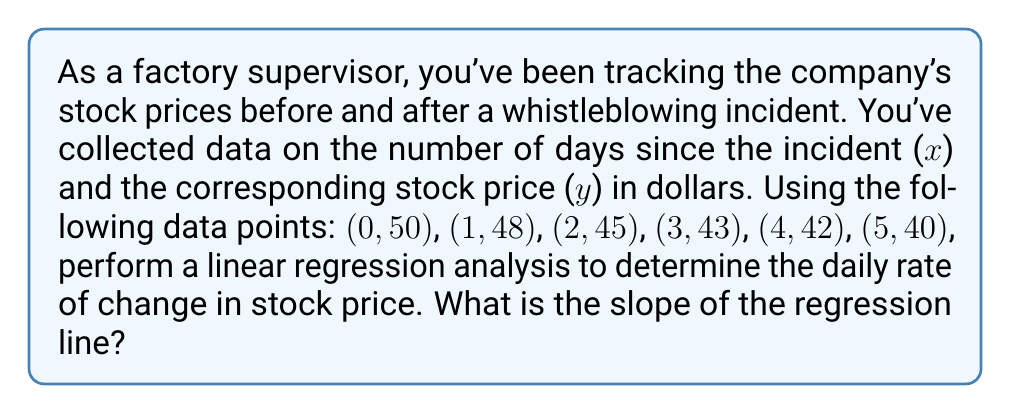Help me with this question. To find the slope of the regression line, we'll use the formula:

$$ m = \frac{n\sum xy - \sum x \sum y}{n\sum x^2 - (\sum x)^2} $$

Where:
$n$ is the number of data points
$x$ is the number of days since the incident
$y$ is the stock price

Step 1: Calculate the required sums:
$n = 6$
$\sum x = 0 + 1 + 2 + 3 + 4 + 5 = 15$
$\sum y = 50 + 48 + 45 + 43 + 42 + 40 = 268$
$\sum xy = 0(50) + 1(48) + 2(45) + 3(43) + 4(42) + 5(40) = 610$
$\sum x^2 = 0^2 + 1^2 + 2^2 + 3^2 + 4^2 + 5^2 = 55$

Step 2: Substitute these values into the slope formula:

$$ m = \frac{6(610) - 15(268)}{6(55) - 15^2} $$

Step 3: Simplify:

$$ m = \frac{3660 - 4020}{330 - 225} = \frac{-360}{105} $$

Step 4: Calculate the final result:

$$ m = -\frac{24}{7} \approx -3.43 $$
Answer: $-\frac{24}{7}$ 